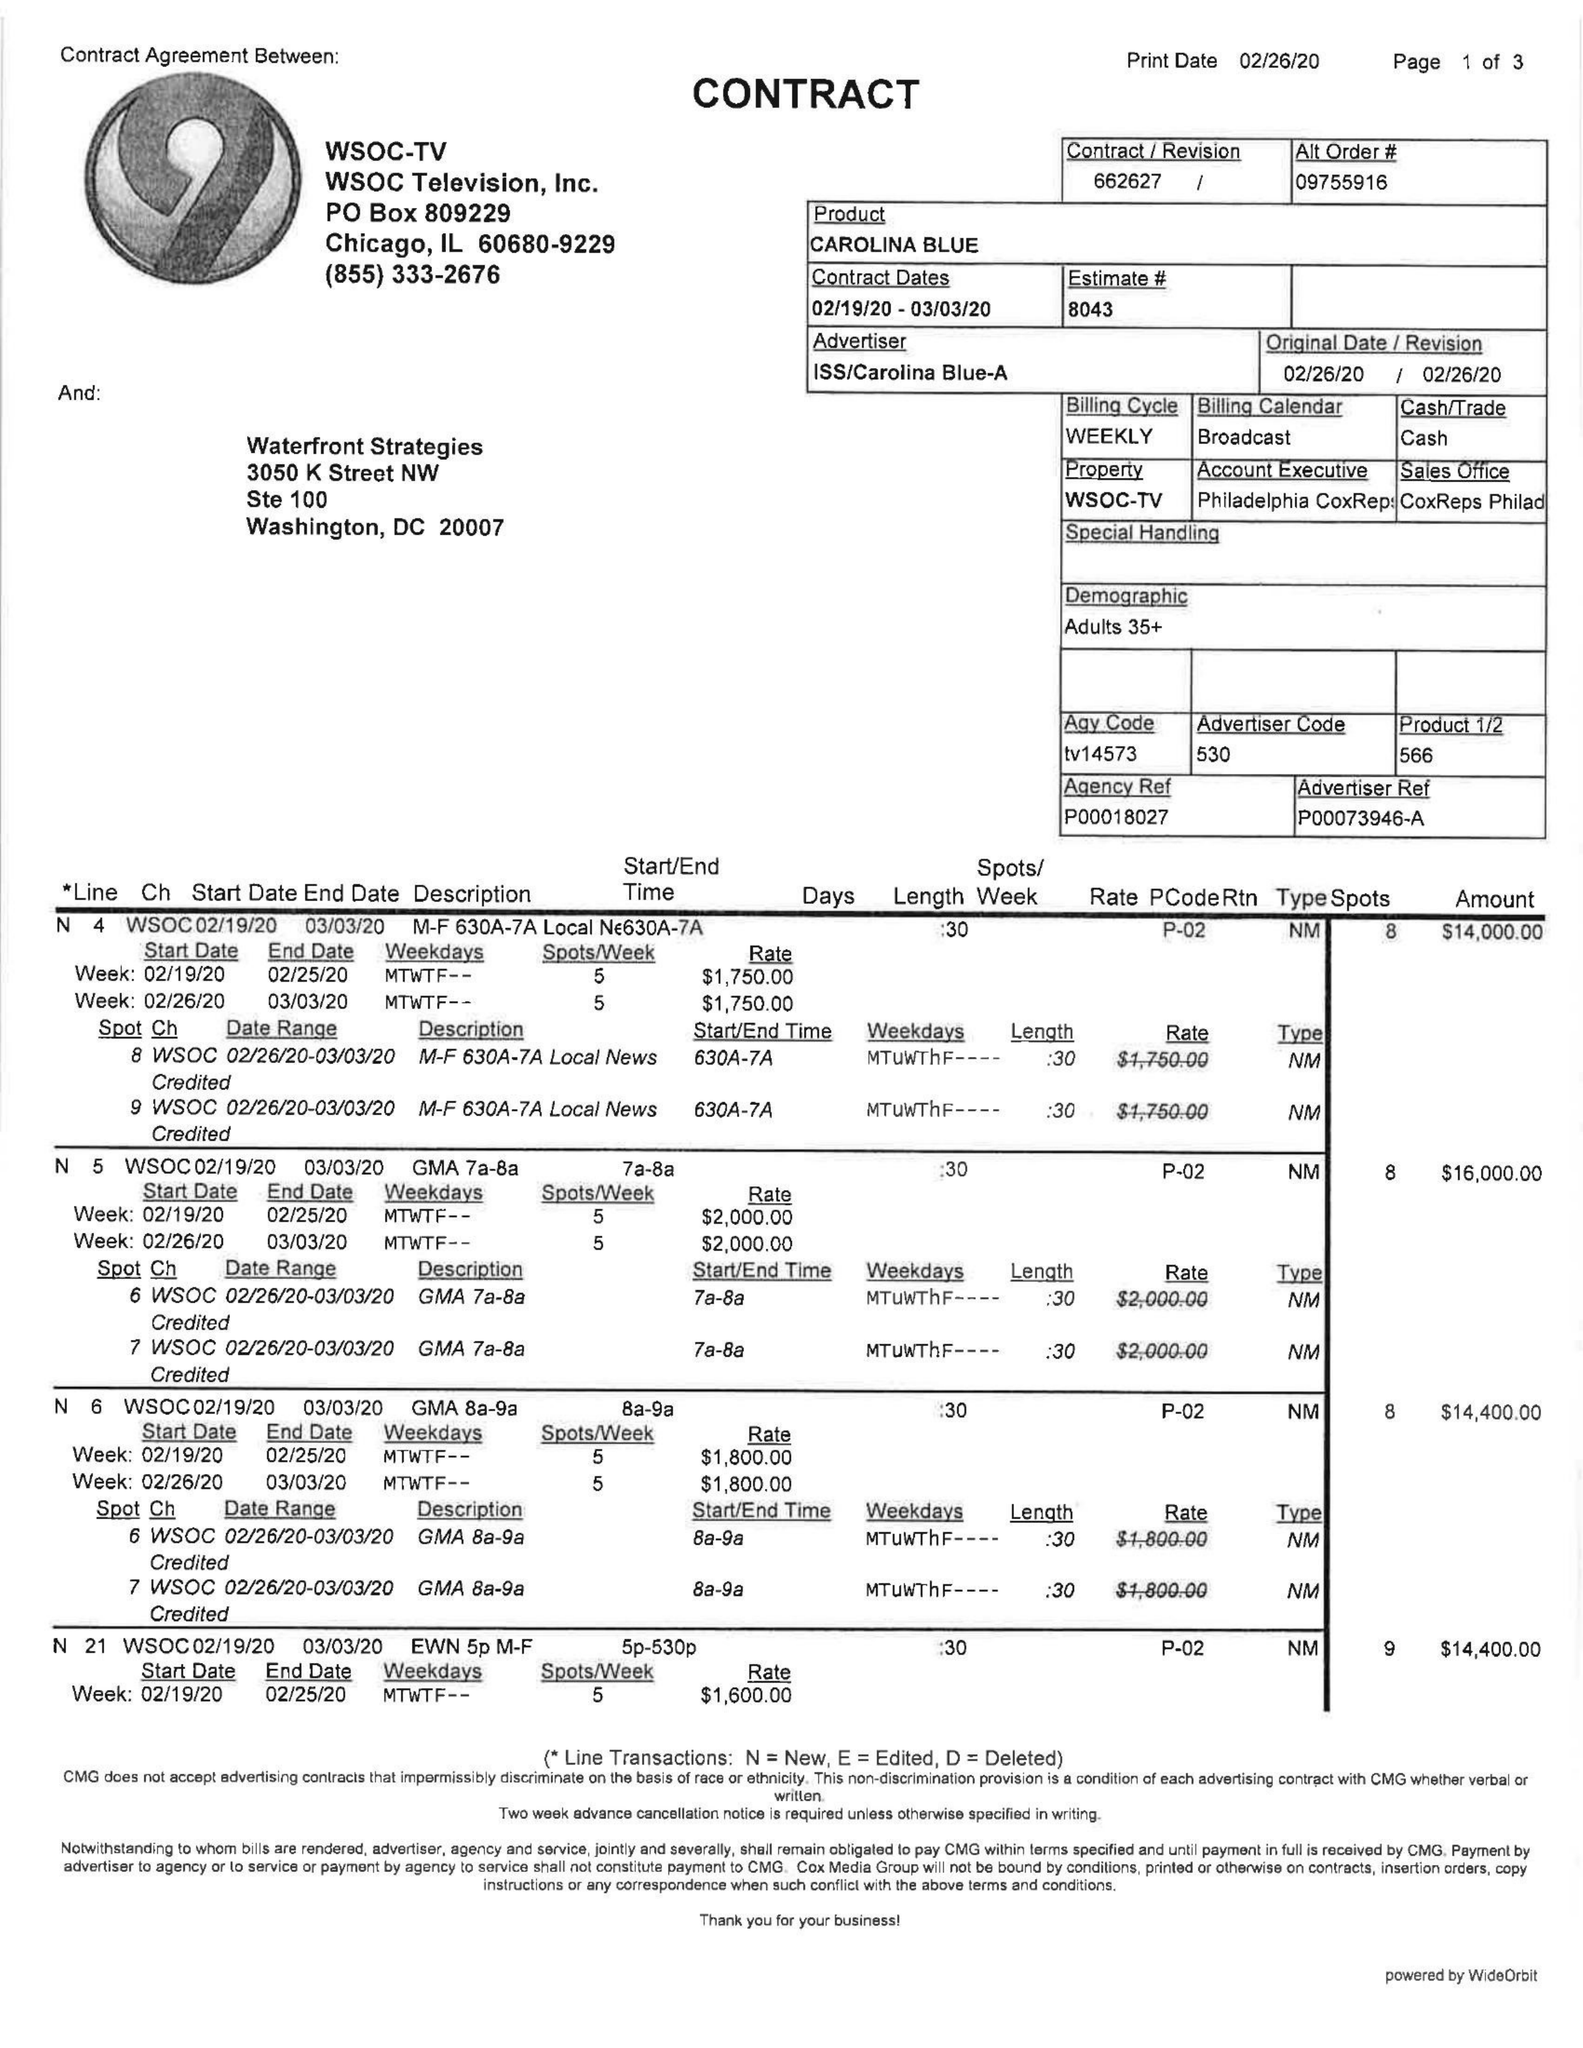What is the value for the flight_to?
Answer the question using a single word or phrase. 03/03/20 